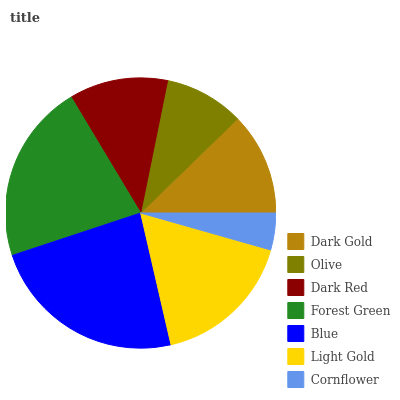Is Cornflower the minimum?
Answer yes or no. Yes. Is Blue the maximum?
Answer yes or no. Yes. Is Olive the minimum?
Answer yes or no. No. Is Olive the maximum?
Answer yes or no. No. Is Dark Gold greater than Olive?
Answer yes or no. Yes. Is Olive less than Dark Gold?
Answer yes or no. Yes. Is Olive greater than Dark Gold?
Answer yes or no. No. Is Dark Gold less than Olive?
Answer yes or no. No. Is Dark Gold the high median?
Answer yes or no. Yes. Is Dark Gold the low median?
Answer yes or no. Yes. Is Blue the high median?
Answer yes or no. No. Is Dark Red the low median?
Answer yes or no. No. 